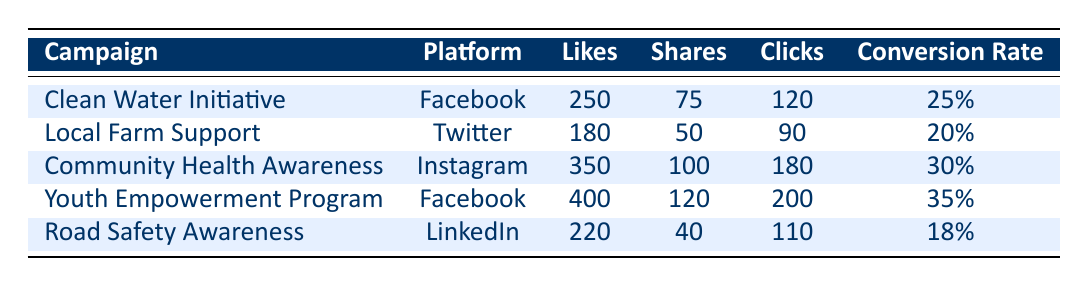What is the total number of likes across all campaigns? To find the total number of likes, we will sum the likes from each campaign: 250 (Clean Water Initiative) + 180 (Local Farm Support) + 350 (Community Health Awareness) + 400 (Youth Empowerment Program) + 220 (Road Safety Awareness) = 1,380
Answer: 1,380 Which platform has the highest conversion rate? By examining the conversion rates for each platform: Facebook has 25% and 35%, Twitter has 20%, Instagram has 30%, and LinkedIn has 18%. The highest conversion rate is 35% from the Youth Empowerment Program on Facebook.
Answer: Facebook How many shares did the Community Health Awareness campaign receive? The Community Health Awareness campaign, which is on Instagram, received 100 shares as indicated in the table.
Answer: 100 Is the conversion rate for the Road Safety Awareness campaign greater than 20%? The table shows that the conversion rate for the Road Safety Awareness campaign is 18%. Since 18% is less than 20%, the answer is no.
Answer: No What is the average number of clicks across all campaigns? We add the clicks for all campaigns: 120 (Clean Water Initiative) + 90 (Local Farm Support) + 180 (Community Health Awareness) + 200 (Youth Empowerment Program) + 110 (Road Safety Awareness) = 700. Then, we divide by the number of campaigns (5): 700 / 5 = 140.
Answer: 140 Which campaign had the most likes and how many? Upon looking through the campaigns, the Youth Empowerment Program had the most likes at 400, which is higher than the likes for all other campaigns.
Answer: 400 Did the Local Farm Support campaign have more comments than the Clean Water Initiative? The Local Farm Support campaign received 30 comments while the Clean Water Initiative received 45 comments. Since 30 is less than 45, the answer is no.
Answer: No What is the combined number of likes and shares for the Youth Empowerment Program? For the Youth Empowerment Program, there were 400 likes and 120 shares. Adding these together gives us 400 + 120 = 520.
Answer: 520 